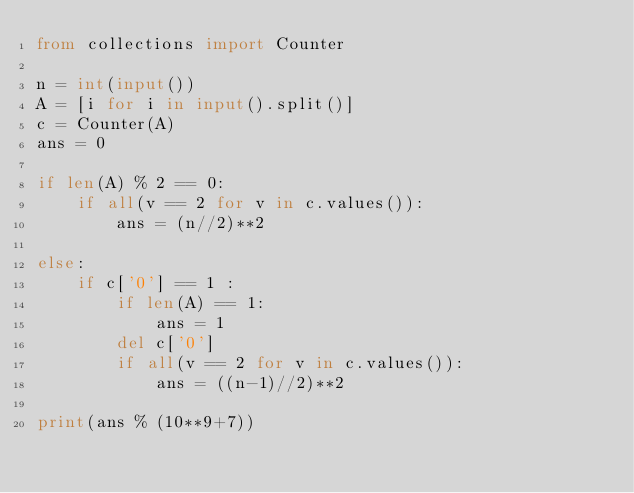Convert code to text. <code><loc_0><loc_0><loc_500><loc_500><_Python_>from collections import Counter

n = int(input())
A = [i for i in input().split()]
c = Counter(A)
ans = 0

if len(A) % 2 == 0:
    if all(v == 2 for v in c.values()):
        ans = (n//2)**2
        
else:
    if c['0'] == 1 :
        if len(A) == 1:
            ans = 1
        del c['0']
        if all(v == 2 for v in c.values()):
            ans = ((n-1)//2)**2

print(ans % (10**9+7))</code> 